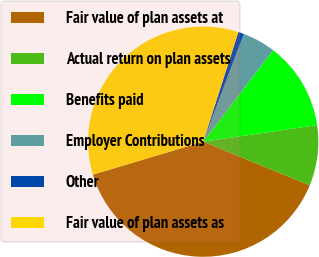Convert chart. <chart><loc_0><loc_0><loc_500><loc_500><pie_chart><fcel>Fair value of plan assets at<fcel>Actual return on plan assets<fcel>Benefits paid<fcel>Employer Contributions<fcel>Other<fcel>Fair value of plan assets as<nl><fcel>39.2%<fcel>8.48%<fcel>12.32%<fcel>4.64%<fcel>0.8%<fcel>34.56%<nl></chart> 